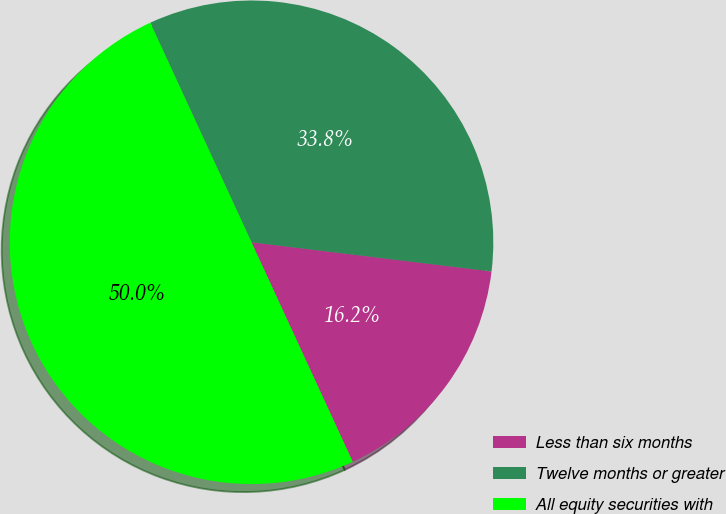Convert chart. <chart><loc_0><loc_0><loc_500><loc_500><pie_chart><fcel>Less than six months<fcel>Twelve months or greater<fcel>All equity securities with<nl><fcel>16.2%<fcel>33.8%<fcel>50.0%<nl></chart> 